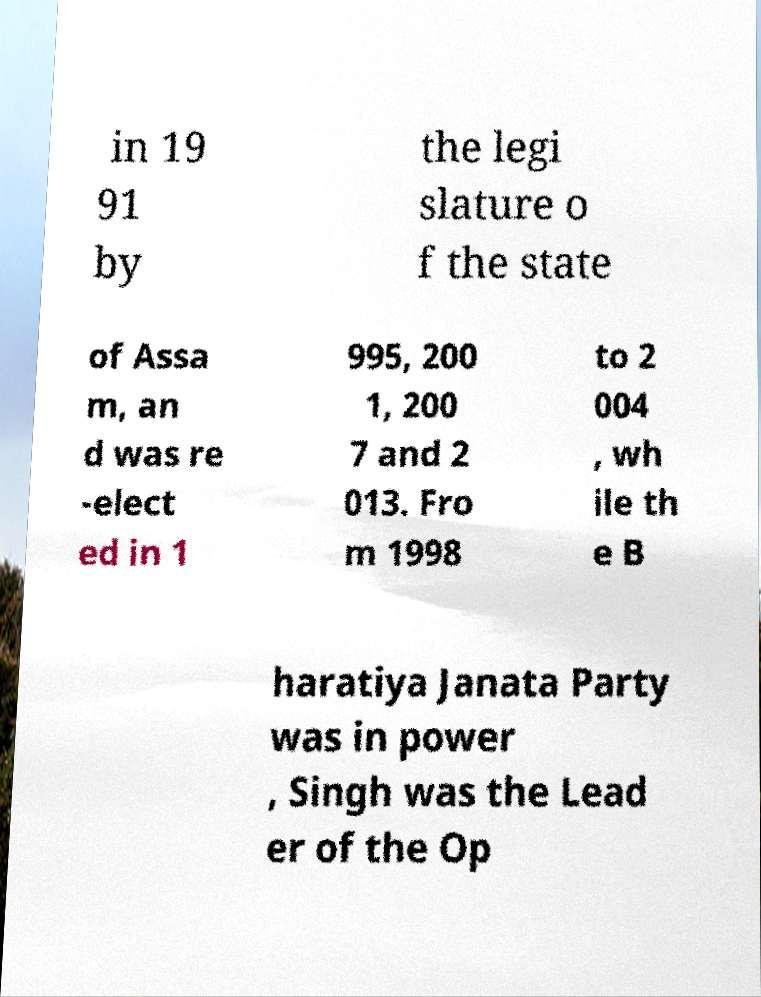Can you read and provide the text displayed in the image?This photo seems to have some interesting text. Can you extract and type it out for me? in 19 91 by the legi slature o f the state of Assa m, an d was re -elect ed in 1 995, 200 1, 200 7 and 2 013. Fro m 1998 to 2 004 , wh ile th e B haratiya Janata Party was in power , Singh was the Lead er of the Op 